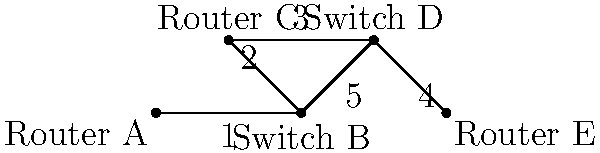In this network diagram, data needs to be sent from Router A to Router E. Assuming the network uses the shortest path routing algorithm, through how many devices (including the source and destination) will the data pass? Let's trace the path of the data step-by-step:

1. The data starts at Router A.
2. From Router A, it must go to Switch B, as this is the only direct connection.
3. At Switch B, we have two options: go to Router C or directly to Switch D.
   - Path through Router C: A → B → C → D → E (5 devices)
   - Path directly to Switch D: A → B → D → E (4 devices)
4. Since the question specifies that the network uses the shortest path routing algorithm, the data will take the path with fewer hops.
5. Therefore, the data will follow the path: Router A → Switch B → Switch D → Router E.

This path includes 4 devices: the source (Router A), two intermediate devices (Switch B and Switch D), and the destination (Router E).
Answer: 4 devices 